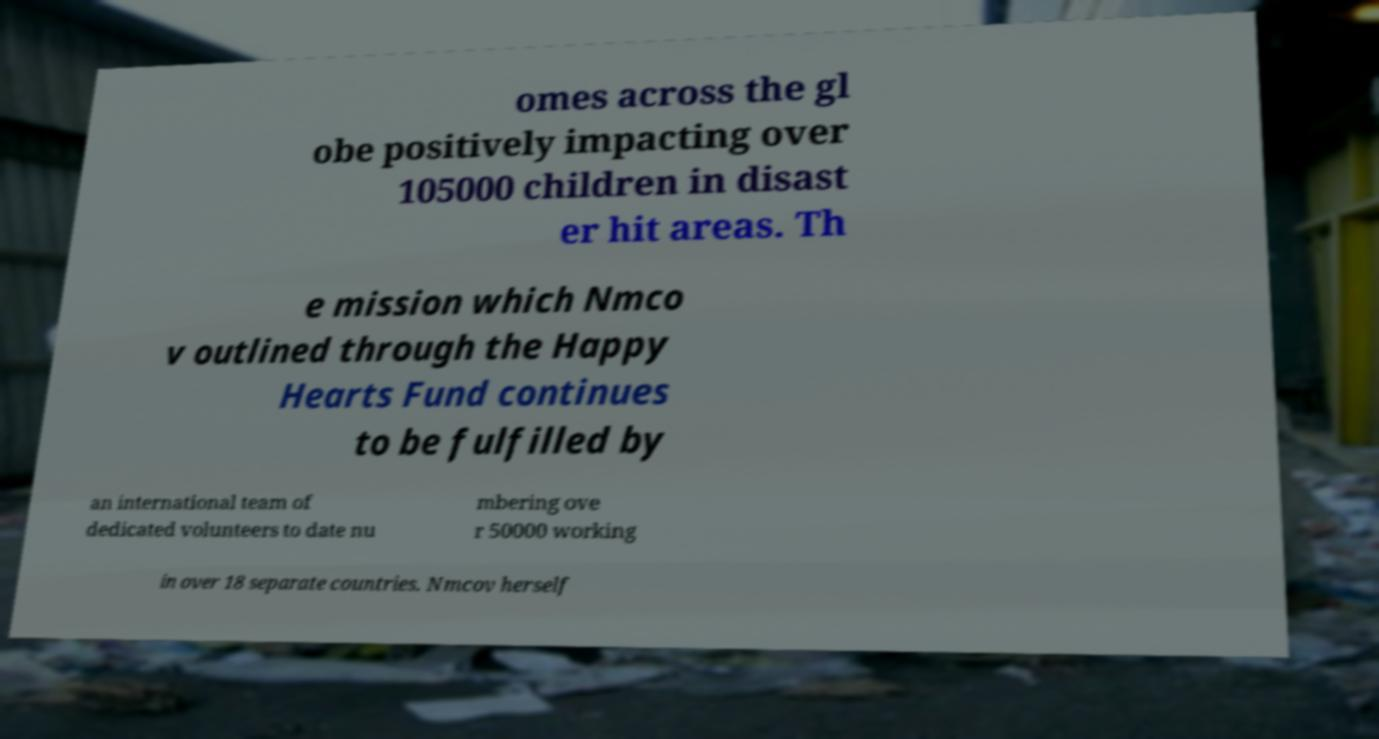Could you extract and type out the text from this image? omes across the gl obe positively impacting over 105000 children in disast er hit areas. Th e mission which Nmco v outlined through the Happy Hearts Fund continues to be fulfilled by an international team of dedicated volunteers to date nu mbering ove r 50000 working in over 18 separate countries. Nmcov herself 